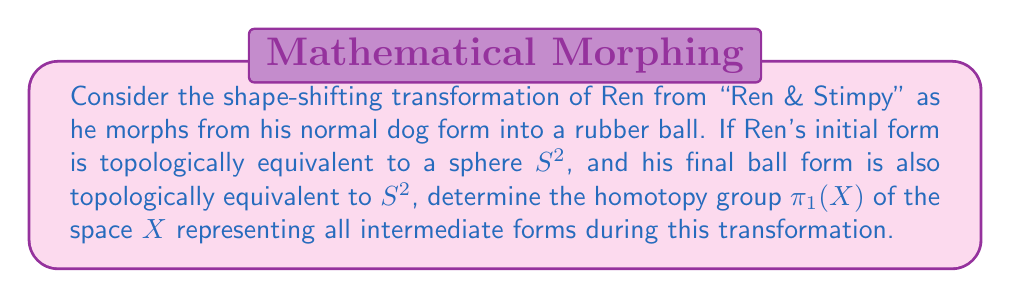What is the answer to this math problem? Let's approach this step-by-step:

1) First, recall that a homotopy is a continuous deformation between two continuous functions. In this case, we're dealing with a deformation of Ren's shape over time.

2) The initial and final forms are both topologically equivalent to $S^2$ (a 2-sphere). This means that the transformation preserves the topological properties of a sphere throughout the process.

3) We can represent this transformation as a continuous function $f: S^2 \times [0,1] \rightarrow X$, where:
   - $S^2$ represents Ren's shape
   - $[0,1]$ represents the time interval of the transformation
   - $X$ is the space of all intermediate forms

4) This function $f$ is essentially a homotopy between the identity map on $S^2$ at $t=0$ and itself at $t=1$.

5) The space $X$ can be thought of as $S^2 \times [0,1]$ with the ends identified, which is topologically equivalent to $S^2 \times S^1$.

6) Now, we need to calculate $\pi_1(X)$, the fundamental group of $X$.

7) Using the fact that $X \simeq S^2 \times S^1$, we can apply the following theorem:
   For simply connected spaces $A$ and $B$, $\pi_1(A \times B) \cong \pi_1(A) \times \pi_1(B)$

8) We know that:
   - $\pi_1(S^2) = 0$ (the sphere is simply connected)
   - $\pi_1(S^1) = \mathbb{Z}$ (the fundamental group of a circle is the integers under addition)

9) Therefore, $\pi_1(X) \cong \pi_1(S^2) \times \pi_1(S^1) \cong 0 \times \mathbb{Z} \cong \mathbb{Z}$
Answer: $\mathbb{Z}$ 